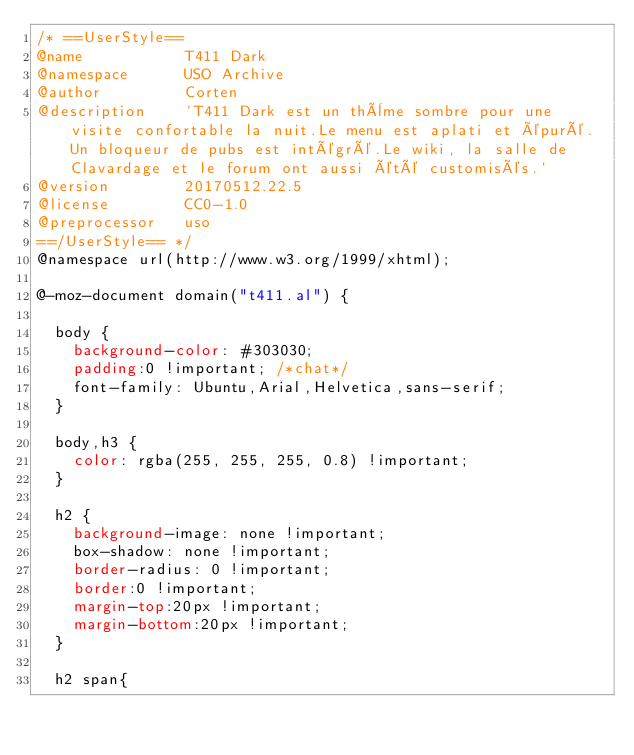Convert code to text. <code><loc_0><loc_0><loc_500><loc_500><_CSS_>/* ==UserStyle==
@name           T411 Dark
@namespace      USO Archive
@author         Corten
@description    `T411 Dark est un thème sombre pour une visite confortable la nuit.Le menu est aplati et épuré.Un bloqueur de pubs est intégré.Le wiki, la salle de Clavardage et le forum ont aussi été customisés.`
@version        20170512.22.5
@license        CC0-1.0
@preprocessor   uso
==/UserStyle== */
@namespace url(http://www.w3.org/1999/xhtml);

@-moz-document domain("t411.al") {

  body {
    background-color: #303030;
    padding:0 !important; /*chat*/
    font-family: Ubuntu,Arial,Helvetica,sans-serif;
  }

  body,h3 {
    color: rgba(255, 255, 255, 0.8) !important;
  }

  h2 {
    background-image: none !important;
    box-shadow: none !important;
    border-radius: 0 !important;
    border:0 !important;
    margin-top:20px !important;
    margin-bottom:20px !important;
  }

  h2 span{</code> 